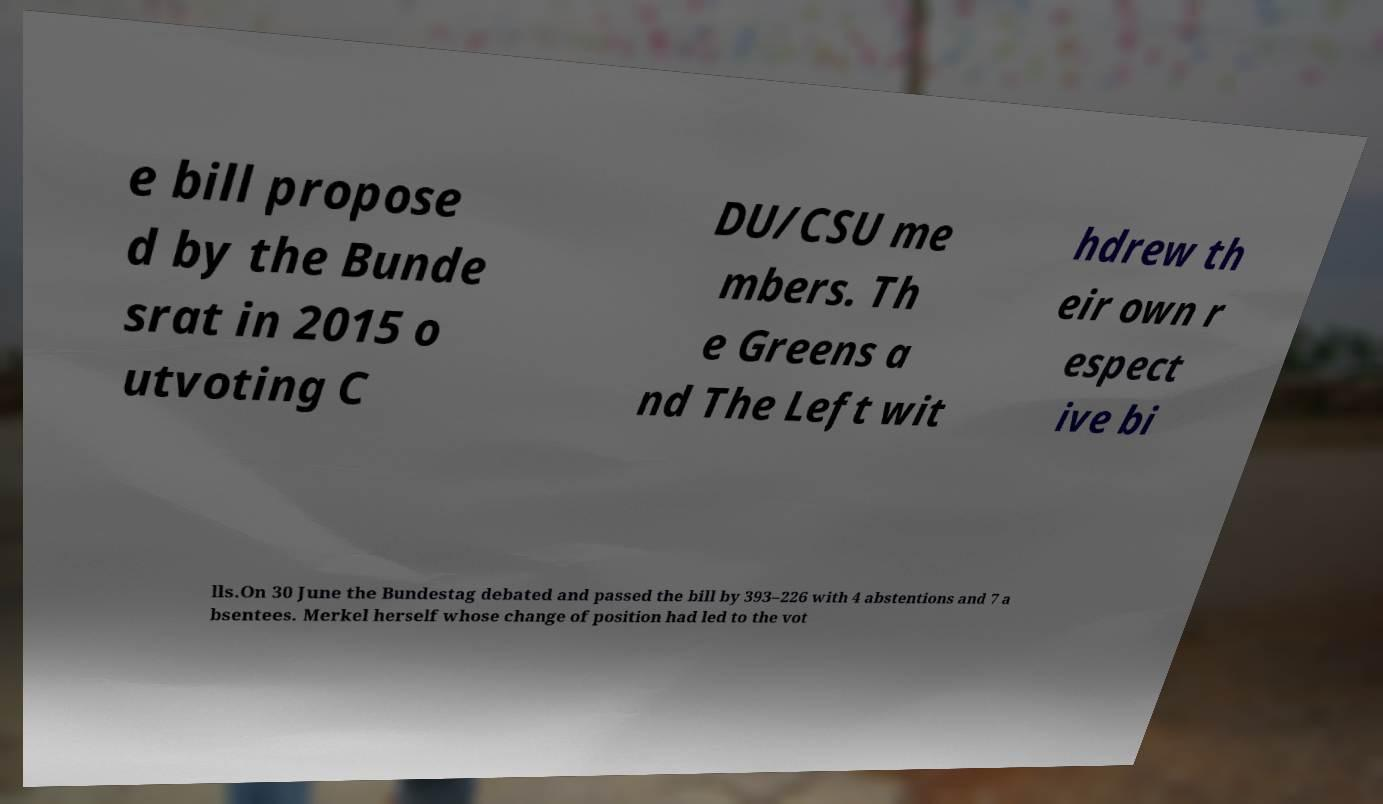What messages or text are displayed in this image? I need them in a readable, typed format. e bill propose d by the Bunde srat in 2015 o utvoting C DU/CSU me mbers. Th e Greens a nd The Left wit hdrew th eir own r espect ive bi lls.On 30 June the Bundestag debated and passed the bill by 393–226 with 4 abstentions and 7 a bsentees. Merkel herself whose change of position had led to the vot 